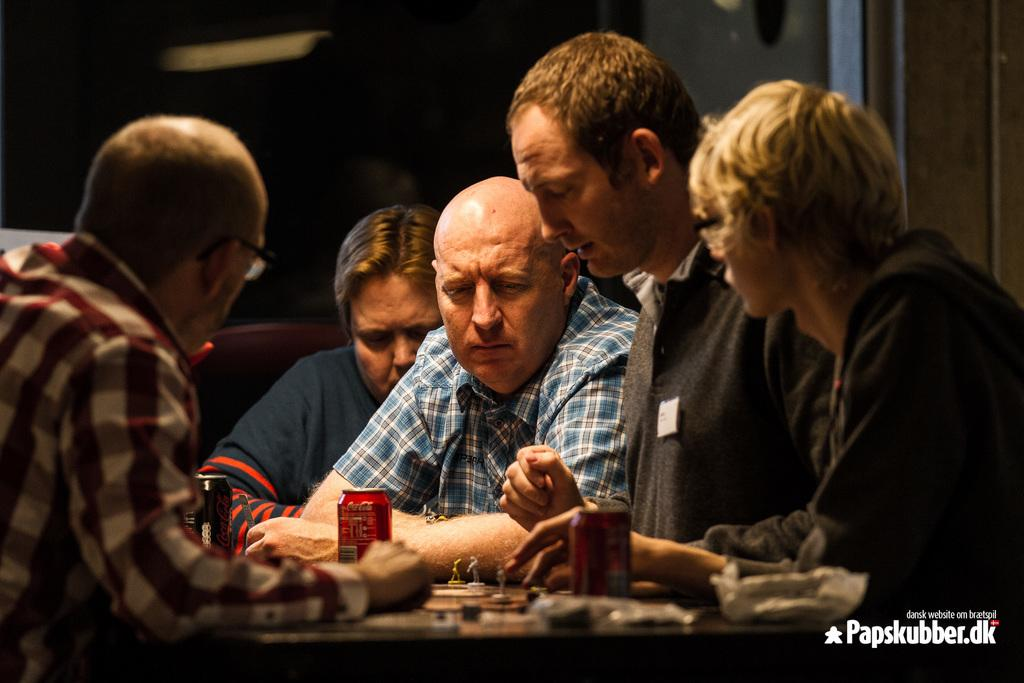Who or what can be seen in the image? There are people in the image. What is present on the table in the image? There are objects on a table in the image. What word is being spelled out by the people in the image? There is no indication in the image that the people are spelling out a word. 